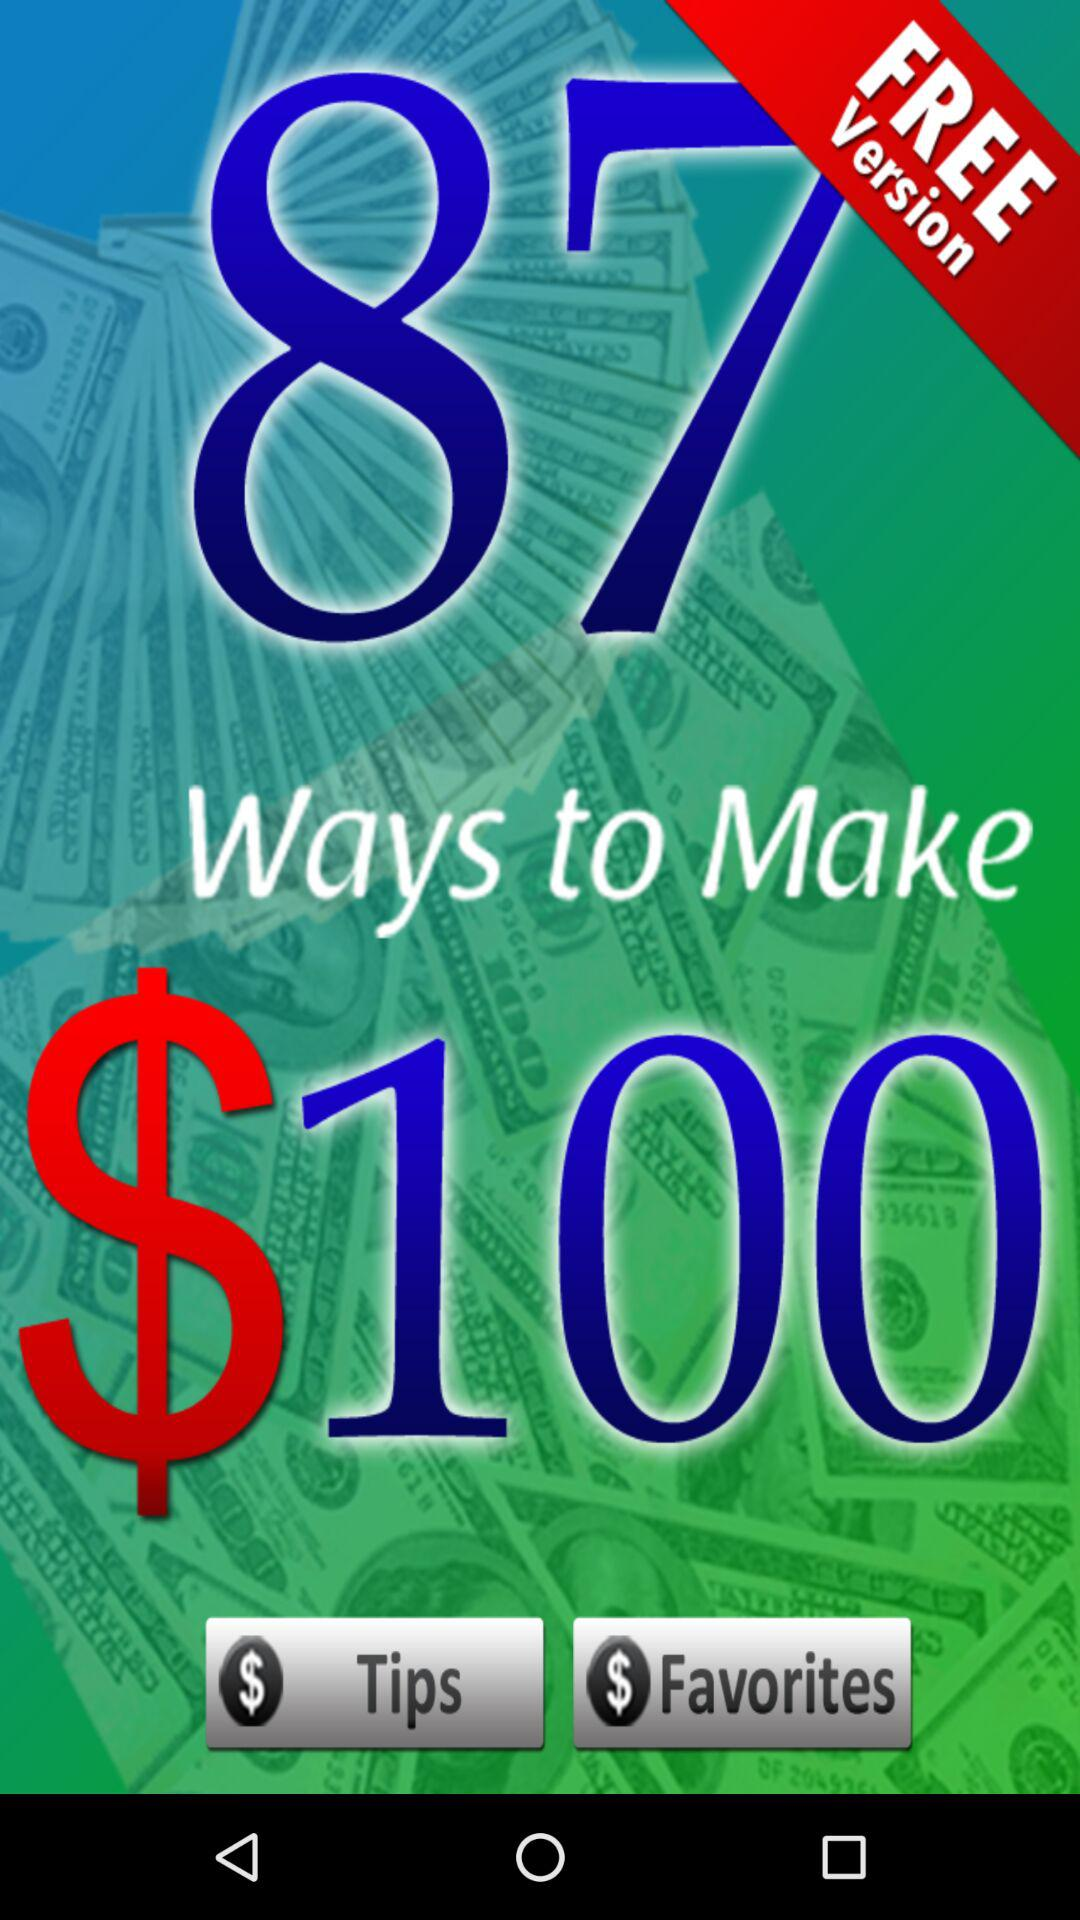Is this version free or paid? This is the free version. 